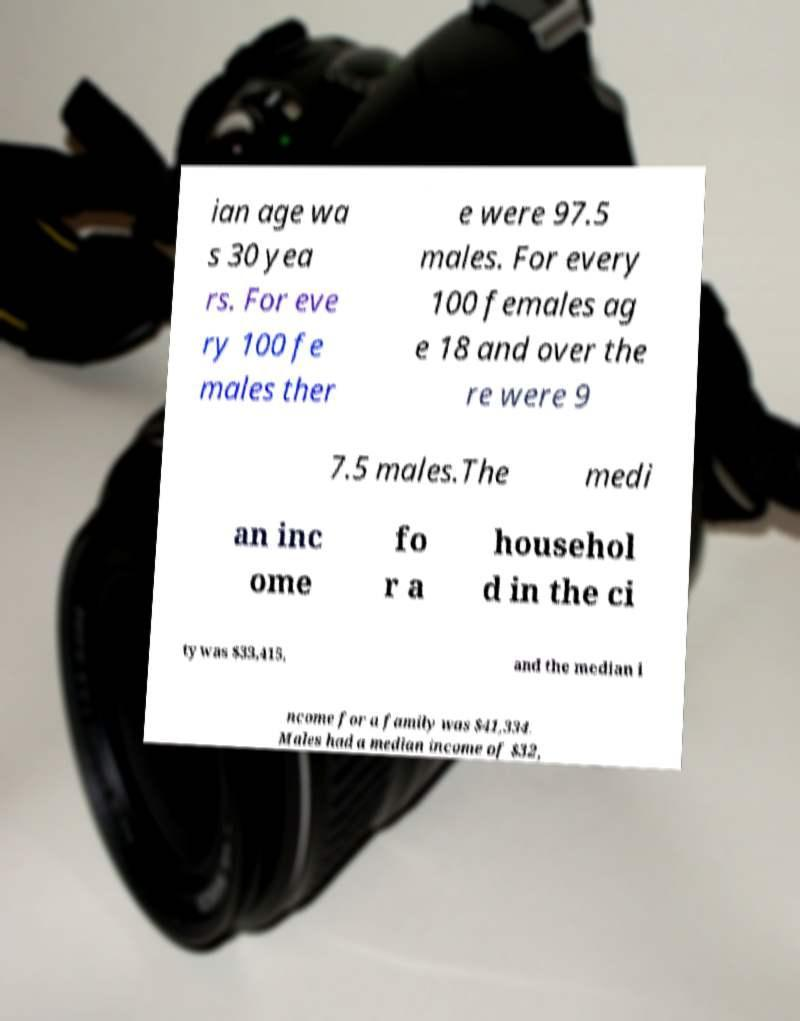Can you read and provide the text displayed in the image?This photo seems to have some interesting text. Can you extract and type it out for me? ian age wa s 30 yea rs. For eve ry 100 fe males ther e were 97.5 males. For every 100 females ag e 18 and over the re were 9 7.5 males.The medi an inc ome fo r a househol d in the ci ty was $33,415, and the median i ncome for a family was $41,334. Males had a median income of $32, 